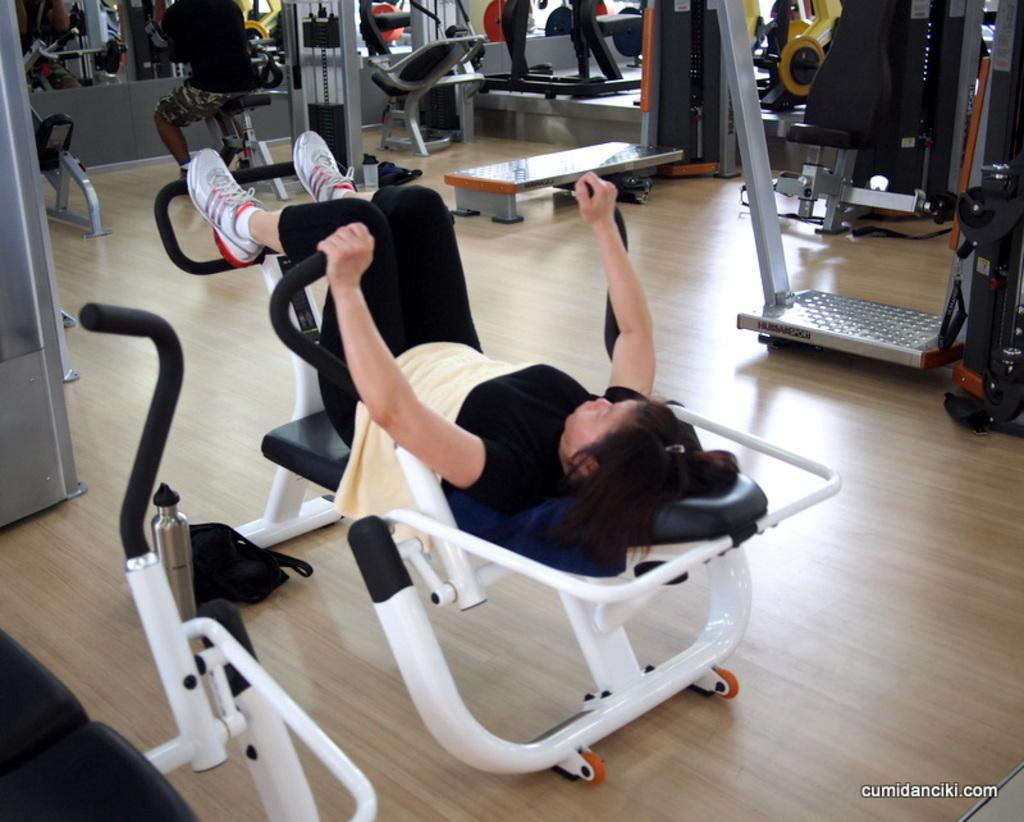What type of equipment can be seen in the image? There is gym equipment in the image. What can be seen on the ground in the image? The floor is visible in the image. What are the people in the image doing? People are working out in the image. Is there any text or logo visible in the image? There is a watermark in the bottom right corner of the image. Can you see a toad on the gym equipment in the image? There is no toad present on the gym equipment in the image. How many faces can be seen on the people working out in the image? The image does not show the faces of the people working out, so it is not possible to determine the number of faces. 